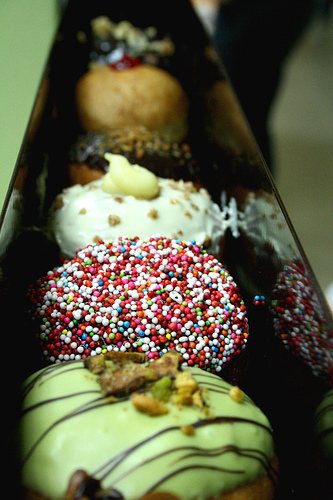Can you tell me how many doughnuts there are in the box? In this box, I can observe there are at least five doughnuts visible, each with a distinct set of toppings. However, due to the angle of the photograph, there might be additional doughnuts that are not visible to the viewer. 